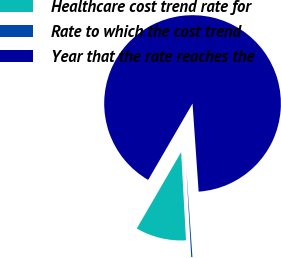Convert chart to OTSL. <chart><loc_0><loc_0><loc_500><loc_500><pie_chart><fcel>Healthcare cost trend rate for<fcel>Rate to which the cost trend<fcel>Year that the rate reaches the<nl><fcel>9.25%<fcel>0.22%<fcel>90.52%<nl></chart> 